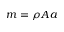<formula> <loc_0><loc_0><loc_500><loc_500>m = \rho A a</formula> 